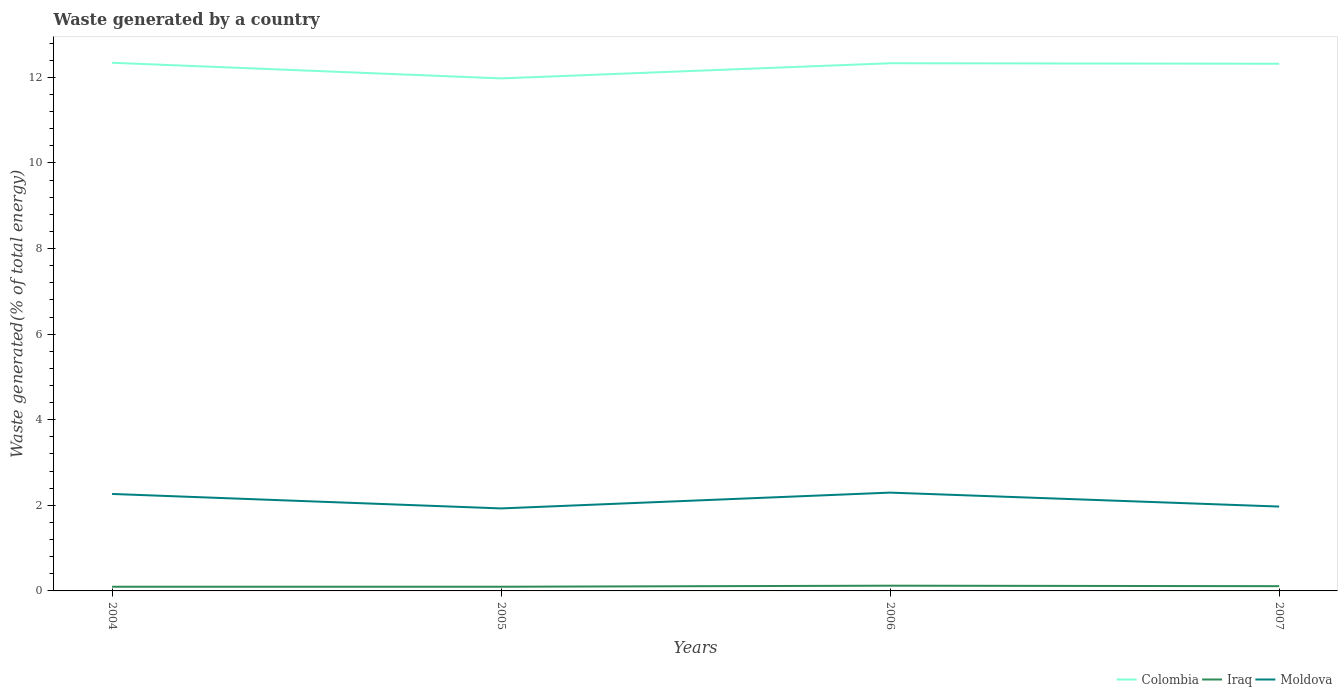How many different coloured lines are there?
Your answer should be very brief. 3. Does the line corresponding to Moldova intersect with the line corresponding to Colombia?
Provide a short and direct response. No. Across all years, what is the maximum total waste generated in Colombia?
Provide a succinct answer. 11.98. In which year was the total waste generated in Iraq maximum?
Make the answer very short. 2004. What is the total total waste generated in Colombia in the graph?
Give a very brief answer. 0.01. What is the difference between the highest and the second highest total waste generated in Iraq?
Keep it short and to the point. 0.02. What is the difference between the highest and the lowest total waste generated in Iraq?
Keep it short and to the point. 2. Is the total waste generated in Colombia strictly greater than the total waste generated in Moldova over the years?
Keep it short and to the point. No. How many lines are there?
Your response must be concise. 3. What is the difference between two consecutive major ticks on the Y-axis?
Your response must be concise. 2. Are the values on the major ticks of Y-axis written in scientific E-notation?
Keep it short and to the point. No. Does the graph contain grids?
Your answer should be compact. No. Where does the legend appear in the graph?
Your answer should be very brief. Bottom right. How many legend labels are there?
Offer a terse response. 3. How are the legend labels stacked?
Offer a terse response. Horizontal. What is the title of the graph?
Offer a very short reply. Waste generated by a country. What is the label or title of the X-axis?
Ensure brevity in your answer.  Years. What is the label or title of the Y-axis?
Provide a short and direct response. Waste generated(% of total energy). What is the Waste generated(% of total energy) of Colombia in 2004?
Provide a succinct answer. 12.34. What is the Waste generated(% of total energy) in Iraq in 2004?
Your response must be concise. 0.1. What is the Waste generated(% of total energy) in Moldova in 2004?
Ensure brevity in your answer.  2.27. What is the Waste generated(% of total energy) of Colombia in 2005?
Offer a terse response. 11.98. What is the Waste generated(% of total energy) of Iraq in 2005?
Offer a terse response. 0.1. What is the Waste generated(% of total energy) of Moldova in 2005?
Offer a very short reply. 1.93. What is the Waste generated(% of total energy) of Colombia in 2006?
Offer a terse response. 12.33. What is the Waste generated(% of total energy) in Iraq in 2006?
Give a very brief answer. 0.12. What is the Waste generated(% of total energy) in Moldova in 2006?
Your answer should be very brief. 2.3. What is the Waste generated(% of total energy) of Colombia in 2007?
Provide a short and direct response. 12.32. What is the Waste generated(% of total energy) of Iraq in 2007?
Your answer should be very brief. 0.11. What is the Waste generated(% of total energy) of Moldova in 2007?
Ensure brevity in your answer.  1.97. Across all years, what is the maximum Waste generated(% of total energy) in Colombia?
Keep it short and to the point. 12.34. Across all years, what is the maximum Waste generated(% of total energy) in Iraq?
Provide a succinct answer. 0.12. Across all years, what is the maximum Waste generated(% of total energy) of Moldova?
Offer a terse response. 2.3. Across all years, what is the minimum Waste generated(% of total energy) in Colombia?
Give a very brief answer. 11.98. Across all years, what is the minimum Waste generated(% of total energy) in Iraq?
Provide a short and direct response. 0.1. Across all years, what is the minimum Waste generated(% of total energy) of Moldova?
Ensure brevity in your answer.  1.93. What is the total Waste generated(% of total energy) of Colombia in the graph?
Ensure brevity in your answer.  48.96. What is the total Waste generated(% of total energy) of Iraq in the graph?
Keep it short and to the point. 0.43. What is the total Waste generated(% of total energy) of Moldova in the graph?
Your answer should be compact. 8.46. What is the difference between the Waste generated(% of total energy) in Colombia in 2004 and that in 2005?
Provide a short and direct response. 0.36. What is the difference between the Waste generated(% of total energy) in Iraq in 2004 and that in 2005?
Provide a succinct answer. -0. What is the difference between the Waste generated(% of total energy) in Moldova in 2004 and that in 2005?
Your answer should be very brief. 0.34. What is the difference between the Waste generated(% of total energy) of Colombia in 2004 and that in 2006?
Provide a short and direct response. 0.01. What is the difference between the Waste generated(% of total energy) in Iraq in 2004 and that in 2006?
Give a very brief answer. -0.02. What is the difference between the Waste generated(% of total energy) of Moldova in 2004 and that in 2006?
Offer a terse response. -0.03. What is the difference between the Waste generated(% of total energy) in Colombia in 2004 and that in 2007?
Your answer should be compact. 0.02. What is the difference between the Waste generated(% of total energy) of Iraq in 2004 and that in 2007?
Your answer should be very brief. -0.01. What is the difference between the Waste generated(% of total energy) in Moldova in 2004 and that in 2007?
Your answer should be very brief. 0.29. What is the difference between the Waste generated(% of total energy) in Colombia in 2005 and that in 2006?
Offer a very short reply. -0.35. What is the difference between the Waste generated(% of total energy) in Iraq in 2005 and that in 2006?
Ensure brevity in your answer.  -0.02. What is the difference between the Waste generated(% of total energy) of Moldova in 2005 and that in 2006?
Offer a very short reply. -0.37. What is the difference between the Waste generated(% of total energy) of Colombia in 2005 and that in 2007?
Ensure brevity in your answer.  -0.34. What is the difference between the Waste generated(% of total energy) of Iraq in 2005 and that in 2007?
Make the answer very short. -0.01. What is the difference between the Waste generated(% of total energy) in Moldova in 2005 and that in 2007?
Provide a succinct answer. -0.04. What is the difference between the Waste generated(% of total energy) in Colombia in 2006 and that in 2007?
Make the answer very short. 0.01. What is the difference between the Waste generated(% of total energy) in Iraq in 2006 and that in 2007?
Keep it short and to the point. 0.01. What is the difference between the Waste generated(% of total energy) of Moldova in 2006 and that in 2007?
Provide a short and direct response. 0.33. What is the difference between the Waste generated(% of total energy) in Colombia in 2004 and the Waste generated(% of total energy) in Iraq in 2005?
Give a very brief answer. 12.24. What is the difference between the Waste generated(% of total energy) in Colombia in 2004 and the Waste generated(% of total energy) in Moldova in 2005?
Offer a very short reply. 10.41. What is the difference between the Waste generated(% of total energy) of Iraq in 2004 and the Waste generated(% of total energy) of Moldova in 2005?
Your answer should be very brief. -1.83. What is the difference between the Waste generated(% of total energy) in Colombia in 2004 and the Waste generated(% of total energy) in Iraq in 2006?
Give a very brief answer. 12.22. What is the difference between the Waste generated(% of total energy) of Colombia in 2004 and the Waste generated(% of total energy) of Moldova in 2006?
Offer a very short reply. 10.04. What is the difference between the Waste generated(% of total energy) in Iraq in 2004 and the Waste generated(% of total energy) in Moldova in 2006?
Your answer should be compact. -2.2. What is the difference between the Waste generated(% of total energy) of Colombia in 2004 and the Waste generated(% of total energy) of Iraq in 2007?
Provide a short and direct response. 12.23. What is the difference between the Waste generated(% of total energy) in Colombia in 2004 and the Waste generated(% of total energy) in Moldova in 2007?
Keep it short and to the point. 10.37. What is the difference between the Waste generated(% of total energy) in Iraq in 2004 and the Waste generated(% of total energy) in Moldova in 2007?
Keep it short and to the point. -1.87. What is the difference between the Waste generated(% of total energy) of Colombia in 2005 and the Waste generated(% of total energy) of Iraq in 2006?
Your answer should be very brief. 11.85. What is the difference between the Waste generated(% of total energy) in Colombia in 2005 and the Waste generated(% of total energy) in Moldova in 2006?
Give a very brief answer. 9.68. What is the difference between the Waste generated(% of total energy) in Iraq in 2005 and the Waste generated(% of total energy) in Moldova in 2006?
Provide a succinct answer. -2.2. What is the difference between the Waste generated(% of total energy) in Colombia in 2005 and the Waste generated(% of total energy) in Iraq in 2007?
Offer a very short reply. 11.87. What is the difference between the Waste generated(% of total energy) of Colombia in 2005 and the Waste generated(% of total energy) of Moldova in 2007?
Make the answer very short. 10. What is the difference between the Waste generated(% of total energy) of Iraq in 2005 and the Waste generated(% of total energy) of Moldova in 2007?
Make the answer very short. -1.87. What is the difference between the Waste generated(% of total energy) of Colombia in 2006 and the Waste generated(% of total energy) of Iraq in 2007?
Keep it short and to the point. 12.22. What is the difference between the Waste generated(% of total energy) of Colombia in 2006 and the Waste generated(% of total energy) of Moldova in 2007?
Provide a short and direct response. 10.36. What is the difference between the Waste generated(% of total energy) in Iraq in 2006 and the Waste generated(% of total energy) in Moldova in 2007?
Your answer should be very brief. -1.85. What is the average Waste generated(% of total energy) in Colombia per year?
Offer a very short reply. 12.24. What is the average Waste generated(% of total energy) of Iraq per year?
Make the answer very short. 0.11. What is the average Waste generated(% of total energy) of Moldova per year?
Offer a terse response. 2.12. In the year 2004, what is the difference between the Waste generated(% of total energy) in Colombia and Waste generated(% of total energy) in Iraq?
Provide a short and direct response. 12.24. In the year 2004, what is the difference between the Waste generated(% of total energy) of Colombia and Waste generated(% of total energy) of Moldova?
Keep it short and to the point. 10.07. In the year 2004, what is the difference between the Waste generated(% of total energy) in Iraq and Waste generated(% of total energy) in Moldova?
Provide a short and direct response. -2.17. In the year 2005, what is the difference between the Waste generated(% of total energy) of Colombia and Waste generated(% of total energy) of Iraq?
Offer a terse response. 11.88. In the year 2005, what is the difference between the Waste generated(% of total energy) of Colombia and Waste generated(% of total energy) of Moldova?
Make the answer very short. 10.05. In the year 2005, what is the difference between the Waste generated(% of total energy) of Iraq and Waste generated(% of total energy) of Moldova?
Offer a terse response. -1.83. In the year 2006, what is the difference between the Waste generated(% of total energy) of Colombia and Waste generated(% of total energy) of Iraq?
Provide a short and direct response. 12.21. In the year 2006, what is the difference between the Waste generated(% of total energy) of Colombia and Waste generated(% of total energy) of Moldova?
Provide a succinct answer. 10.03. In the year 2006, what is the difference between the Waste generated(% of total energy) in Iraq and Waste generated(% of total energy) in Moldova?
Offer a terse response. -2.17. In the year 2007, what is the difference between the Waste generated(% of total energy) in Colombia and Waste generated(% of total energy) in Iraq?
Your answer should be very brief. 12.21. In the year 2007, what is the difference between the Waste generated(% of total energy) in Colombia and Waste generated(% of total energy) in Moldova?
Ensure brevity in your answer.  10.35. In the year 2007, what is the difference between the Waste generated(% of total energy) of Iraq and Waste generated(% of total energy) of Moldova?
Your response must be concise. -1.86. What is the ratio of the Waste generated(% of total energy) in Colombia in 2004 to that in 2005?
Your answer should be very brief. 1.03. What is the ratio of the Waste generated(% of total energy) of Iraq in 2004 to that in 2005?
Make the answer very short. 1. What is the ratio of the Waste generated(% of total energy) in Moldova in 2004 to that in 2005?
Ensure brevity in your answer.  1.18. What is the ratio of the Waste generated(% of total energy) in Iraq in 2004 to that in 2006?
Your answer should be very brief. 0.8. What is the ratio of the Waste generated(% of total energy) in Moldova in 2004 to that in 2006?
Your response must be concise. 0.99. What is the ratio of the Waste generated(% of total energy) of Iraq in 2004 to that in 2007?
Offer a terse response. 0.88. What is the ratio of the Waste generated(% of total energy) of Moldova in 2004 to that in 2007?
Give a very brief answer. 1.15. What is the ratio of the Waste generated(% of total energy) in Colombia in 2005 to that in 2006?
Offer a terse response. 0.97. What is the ratio of the Waste generated(% of total energy) in Iraq in 2005 to that in 2006?
Your response must be concise. 0.8. What is the ratio of the Waste generated(% of total energy) of Moldova in 2005 to that in 2006?
Provide a succinct answer. 0.84. What is the ratio of the Waste generated(% of total energy) of Colombia in 2005 to that in 2007?
Your answer should be very brief. 0.97. What is the ratio of the Waste generated(% of total energy) in Iraq in 2005 to that in 2007?
Give a very brief answer. 0.88. What is the ratio of the Waste generated(% of total energy) in Moldova in 2005 to that in 2007?
Provide a short and direct response. 0.98. What is the ratio of the Waste generated(% of total energy) of Iraq in 2006 to that in 2007?
Provide a short and direct response. 1.1. What is the ratio of the Waste generated(% of total energy) in Moldova in 2006 to that in 2007?
Give a very brief answer. 1.17. What is the difference between the highest and the second highest Waste generated(% of total energy) of Colombia?
Offer a terse response. 0.01. What is the difference between the highest and the second highest Waste generated(% of total energy) of Iraq?
Your answer should be compact. 0.01. What is the difference between the highest and the second highest Waste generated(% of total energy) of Moldova?
Ensure brevity in your answer.  0.03. What is the difference between the highest and the lowest Waste generated(% of total energy) in Colombia?
Keep it short and to the point. 0.36. What is the difference between the highest and the lowest Waste generated(% of total energy) in Iraq?
Make the answer very short. 0.02. What is the difference between the highest and the lowest Waste generated(% of total energy) of Moldova?
Offer a terse response. 0.37. 